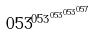Convert formula to latex. <formula><loc_0><loc_0><loc_500><loc_500>0 5 3 ^ { 0 5 3 ^ { 0 5 3 ^ { 0 5 3 ^ { 0 5 7 } } } }</formula> 